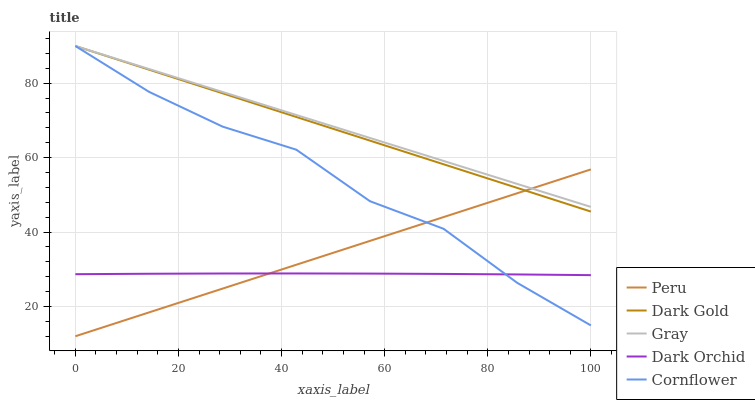Does Dark Orchid have the minimum area under the curve?
Answer yes or no. Yes. Does Gray have the maximum area under the curve?
Answer yes or no. Yes. Does Cornflower have the minimum area under the curve?
Answer yes or no. No. Does Cornflower have the maximum area under the curve?
Answer yes or no. No. Is Peru the smoothest?
Answer yes or no. Yes. Is Cornflower the roughest?
Answer yes or no. Yes. Is Dark Orchid the smoothest?
Answer yes or no. No. Is Dark Orchid the roughest?
Answer yes or no. No. Does Peru have the lowest value?
Answer yes or no. Yes. Does Cornflower have the lowest value?
Answer yes or no. No. Does Dark Gold have the highest value?
Answer yes or no. Yes. Does Dark Orchid have the highest value?
Answer yes or no. No. Is Dark Orchid less than Gray?
Answer yes or no. Yes. Is Gray greater than Dark Orchid?
Answer yes or no. Yes. Does Gray intersect Cornflower?
Answer yes or no. Yes. Is Gray less than Cornflower?
Answer yes or no. No. Is Gray greater than Cornflower?
Answer yes or no. No. Does Dark Orchid intersect Gray?
Answer yes or no. No. 